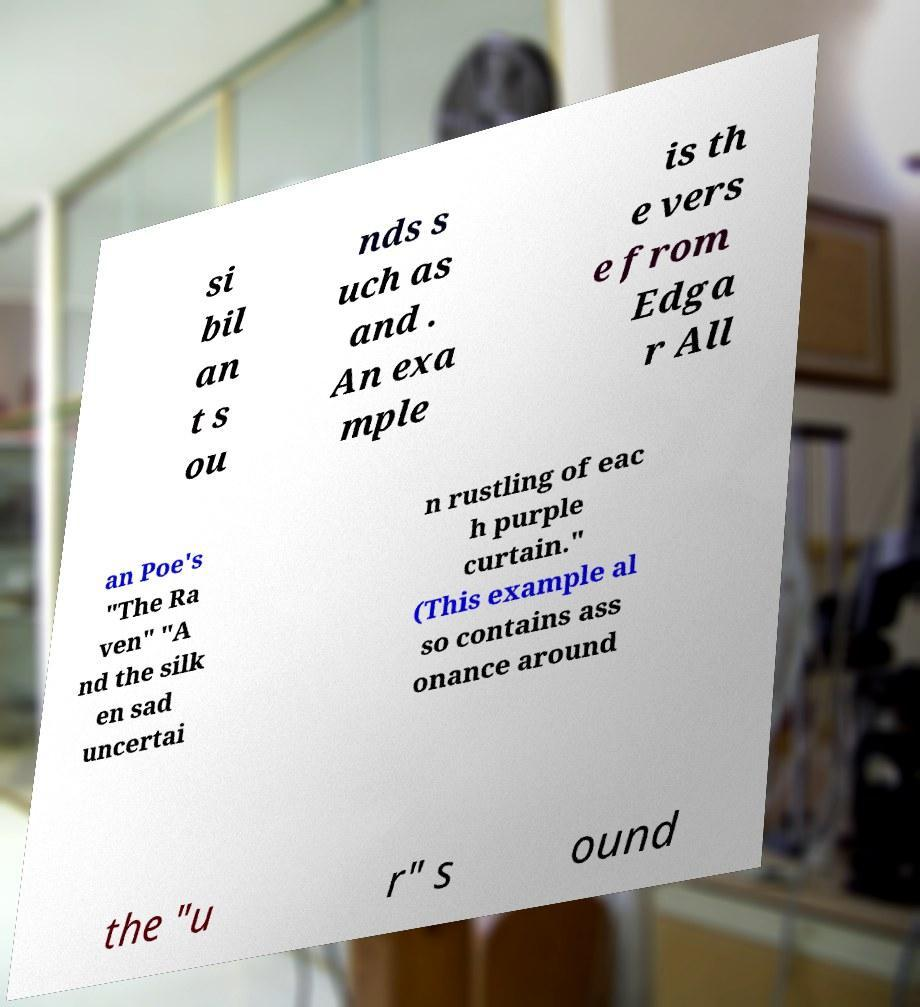Could you assist in decoding the text presented in this image and type it out clearly? si bil an t s ou nds s uch as and . An exa mple is th e vers e from Edga r All an Poe's "The Ra ven" "A nd the silk en sad uncertai n rustling of eac h purple curtain." (This example al so contains ass onance around the "u r" s ound 